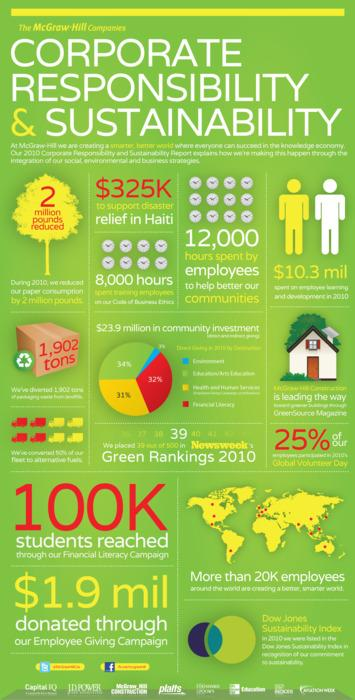Give some essential details in this illustration. The employees spent a total of 12,000 hours to help improve their communities. A total of $325,000 was provided as relief to Haiti. 